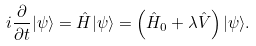<formula> <loc_0><loc_0><loc_500><loc_500>i \frac { \partial } { \partial t } | \psi \rangle = \hat { H } | \psi \rangle = \left ( \hat { H } _ { 0 } + \lambda \hat { V } \right ) | \psi \rangle .</formula> 